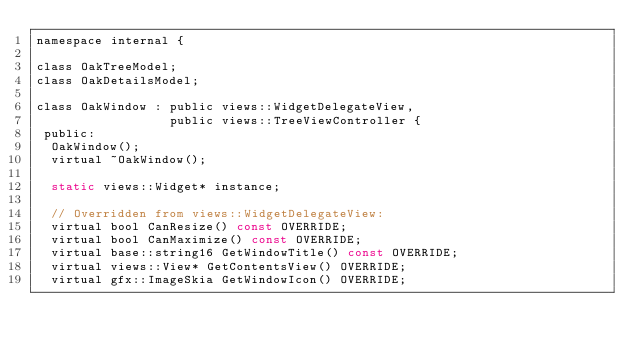<code> <loc_0><loc_0><loc_500><loc_500><_C_>namespace internal {

class OakTreeModel;
class OakDetailsModel;

class OakWindow : public views::WidgetDelegateView,
                  public views::TreeViewController {
 public:
  OakWindow();
  virtual ~OakWindow();

  static views::Widget* instance;

  // Overridden from views::WidgetDelegateView:
  virtual bool CanResize() const OVERRIDE;
  virtual bool CanMaximize() const OVERRIDE;
  virtual base::string16 GetWindowTitle() const OVERRIDE;
  virtual views::View* GetContentsView() OVERRIDE;
  virtual gfx::ImageSkia GetWindowIcon() OVERRIDE;</code> 